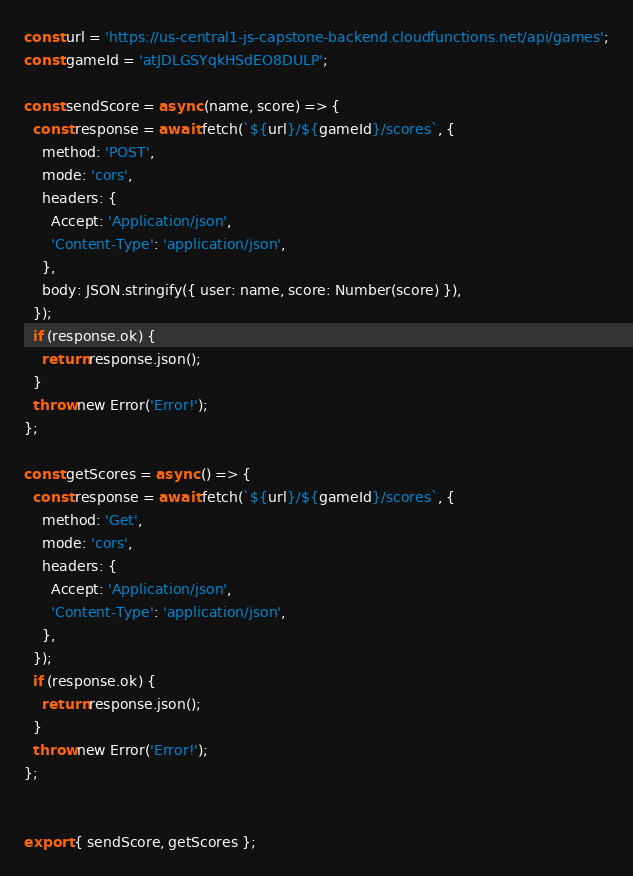<code> <loc_0><loc_0><loc_500><loc_500><_JavaScript_>const url = 'https://us-central1-js-capstone-backend.cloudfunctions.net/api/games';
const gameId = 'atJDLGSYqkHSdEO8DULP';

const sendScore = async (name, score) => {
  const response = await fetch(`${url}/${gameId}/scores`, {
    method: 'POST',
    mode: 'cors',
    headers: {
      Accept: 'Application/json',
      'Content-Type': 'application/json',
    },
    body: JSON.stringify({ user: name, score: Number(score) }),
  });
  if (response.ok) {
    return response.json();
  }
  throw new Error('Error!');
};

const getScores = async () => {
  const response = await fetch(`${url}/${gameId}/scores`, {
    method: 'Get',
    mode: 'cors',
    headers: {
      Accept: 'Application/json',
      'Content-Type': 'application/json',
    },
  });
  if (response.ok) {
    return response.json();
  }
  throw new Error('Error!');
};


export { sendScore, getScores };</code> 